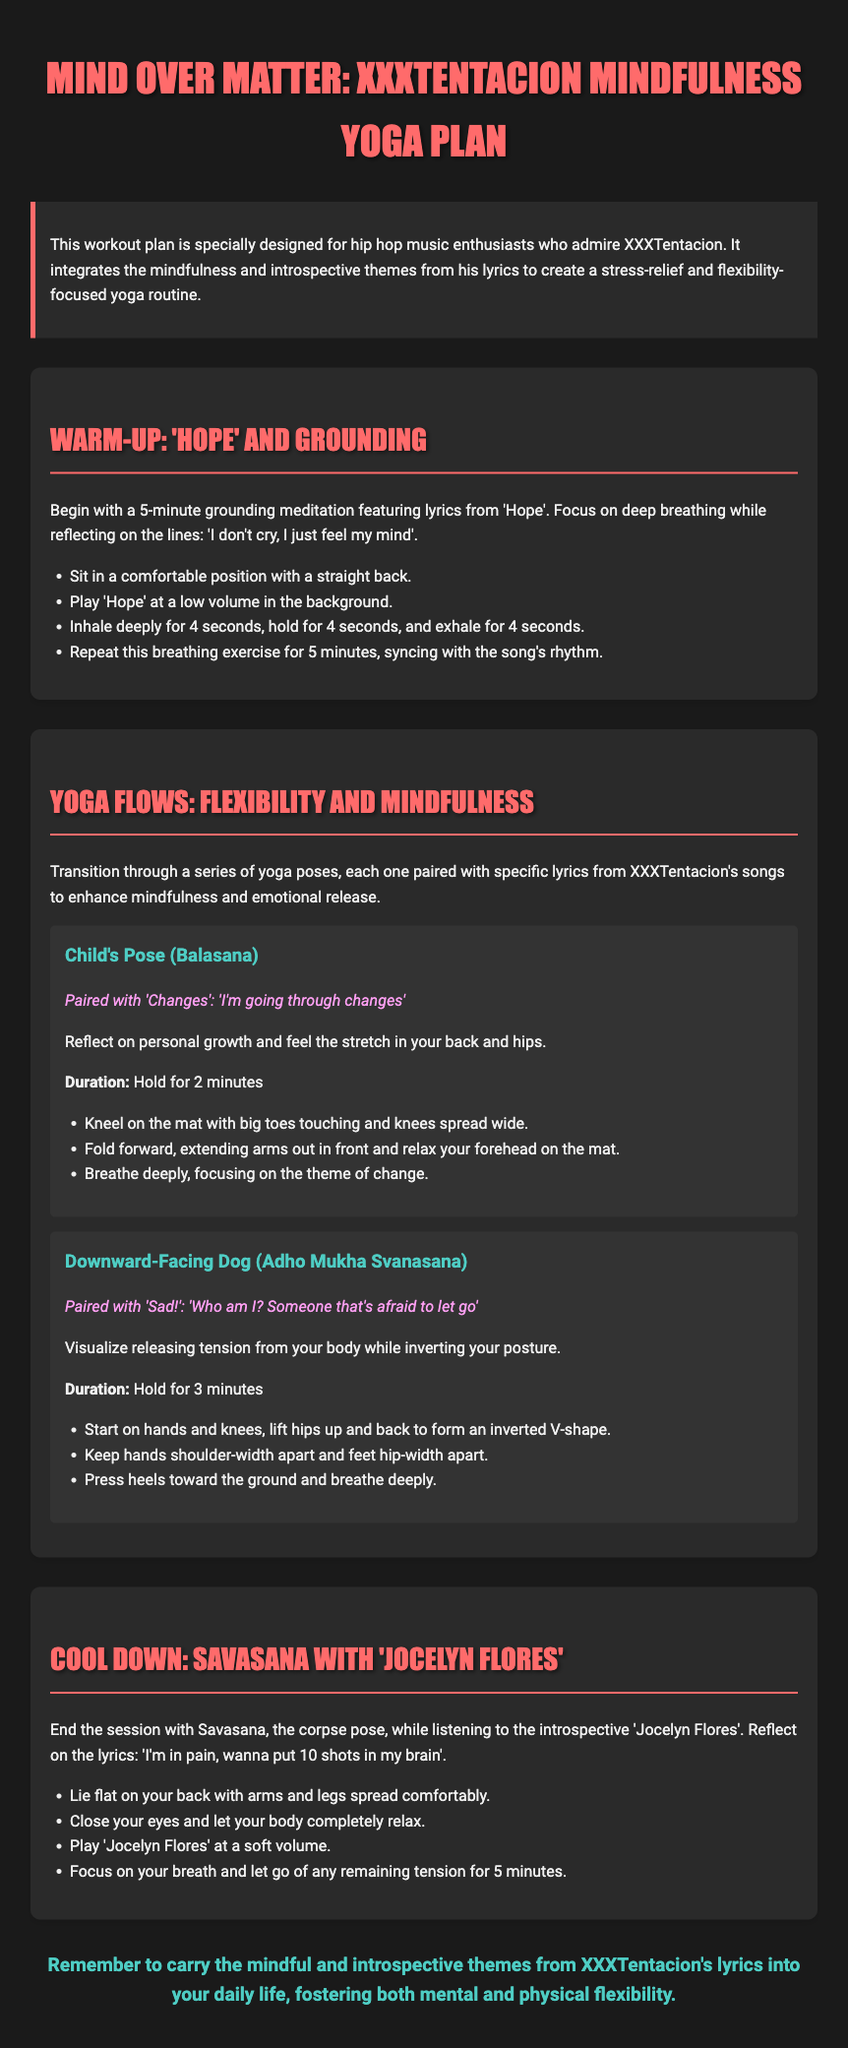What is the title of the workout plan? The title is explicitly stated at the top of the document, which is "Mind Over Matter: XXXTentacion Mindfulness Yoga Plan".
Answer: Mind Over Matter: XXXTentacion Mindfulness Yoga Plan How long should the grounding meditation last? The section on grounding meditation provides the duration of the activity, which is specified as 5 minutes.
Answer: 5 minutes Which song is used for the Child's Pose? The document explicitly mentions the lyrics paired with each yoga pose, including "Changes" for the Child's Pose.
Answer: Changes What is the main theme integrated into the yoga plan? The introduction highlights that the yoga plan integrates mindfulness and introspective themes from XXXTentacion's lyrics.
Answer: Mindfulness and introspective themes How long should you hold the Downward-Facing Dog pose? The duration for holding the Downward-Facing Dog is clearly stated in the text, which is 3 minutes.
Answer: 3 minutes Which song is played during the cool down? The document specifies that "Jocelyn Flores" is played during Savasana, the cool down.
Answer: Jocelyn Flores What is the color of the section headers? The color used for the section headers is described within the style attributes of the document, which indicates they are in a specific color.
Answer: #ff6b6b What should you focus on during the grounding meditation? The grounding meditation section emphasizes focusing on deep breathing and reflecting on specific lyrics.
Answer: Deep breathing and reflecting on lyrics 